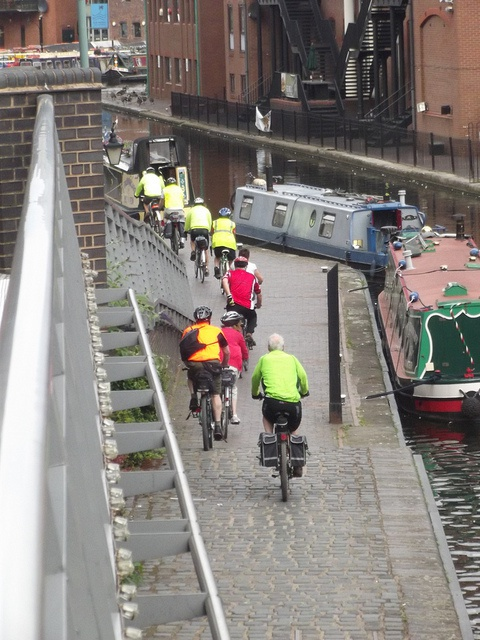Describe the objects in this image and their specific colors. I can see boat in black, lightpink, gray, and darkgray tones, boat in black, darkgray, gray, and lightgray tones, boat in black, gray, darkgray, and ivory tones, people in black, gray, gold, and maroon tones, and people in black, khaki, lightgreen, and darkgreen tones in this image. 